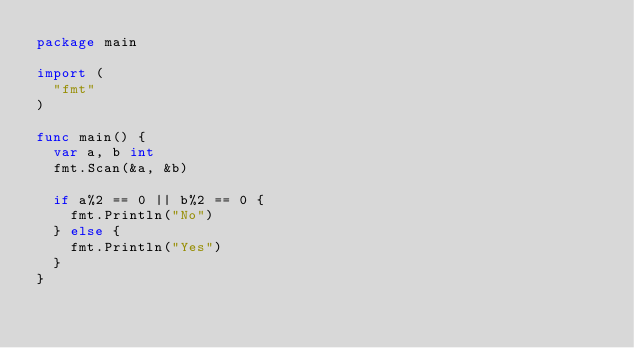<code> <loc_0><loc_0><loc_500><loc_500><_Go_>package main

import (
	"fmt"
)

func main() {
	var a, b int
	fmt.Scan(&a, &b)

	if a%2 == 0 || b%2 == 0 {
		fmt.Println("No")
	} else {
		fmt.Println("Yes")
	}
}
</code> 